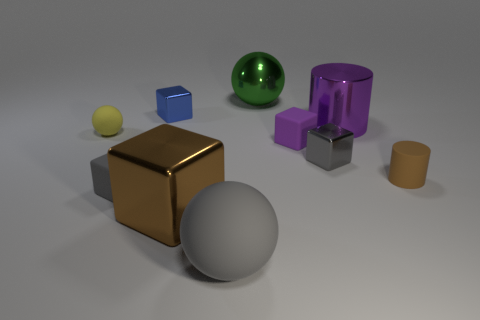Subtract 2 cubes. How many cubes are left? 3 Subtract all blue blocks. How many blocks are left? 4 Subtract all brown metallic cubes. How many cubes are left? 4 Subtract all yellow cubes. Subtract all gray spheres. How many cubes are left? 5 Subtract all cylinders. How many objects are left? 8 Subtract 0 cyan cylinders. How many objects are left? 10 Subtract all small rubber cylinders. Subtract all big matte balls. How many objects are left? 8 Add 8 big cubes. How many big cubes are left? 9 Add 1 small matte cylinders. How many small matte cylinders exist? 2 